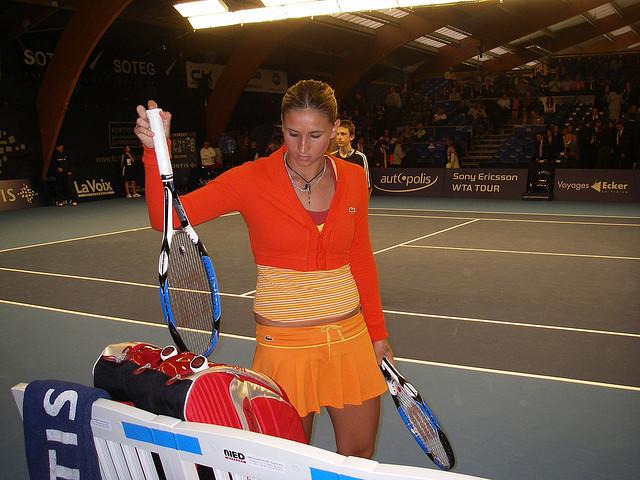What is the woman holding?
Be succinct. Racket. How many rackets is she holding?
Write a very short answer. 2. Is this outdoors?
Quick response, please. No. 